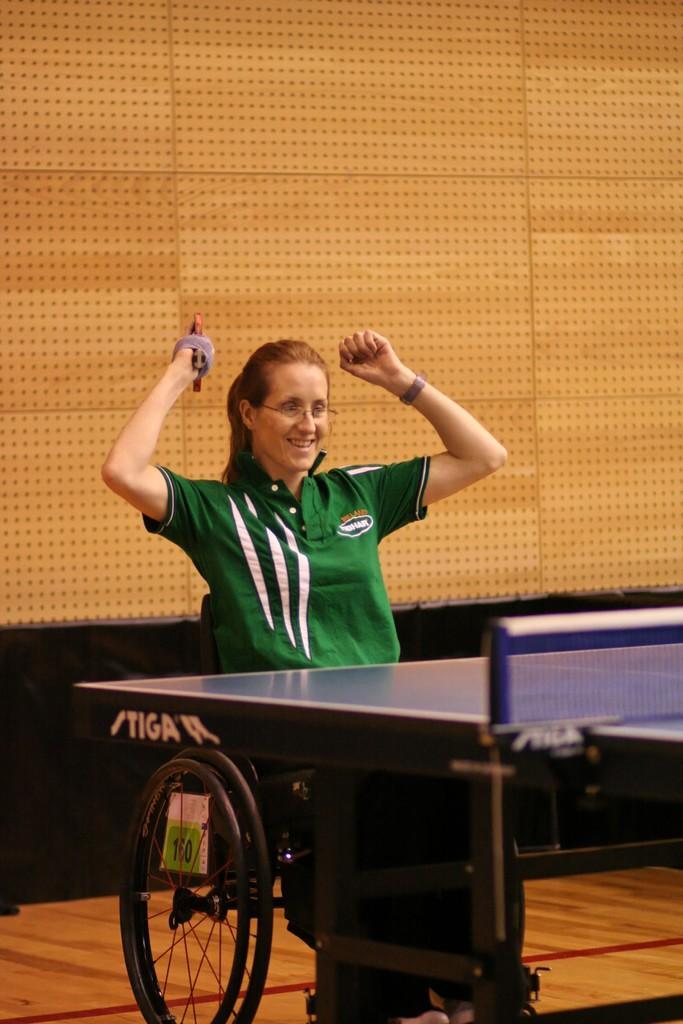How would you summarize this image in a sentence or two? In this image, we can see a woman is smiling and sitting on a wheelchair. She is holding some object. In-front of her, we can see a table with net. At the bottom, there is a wooden floor. Background we can see a wall. 